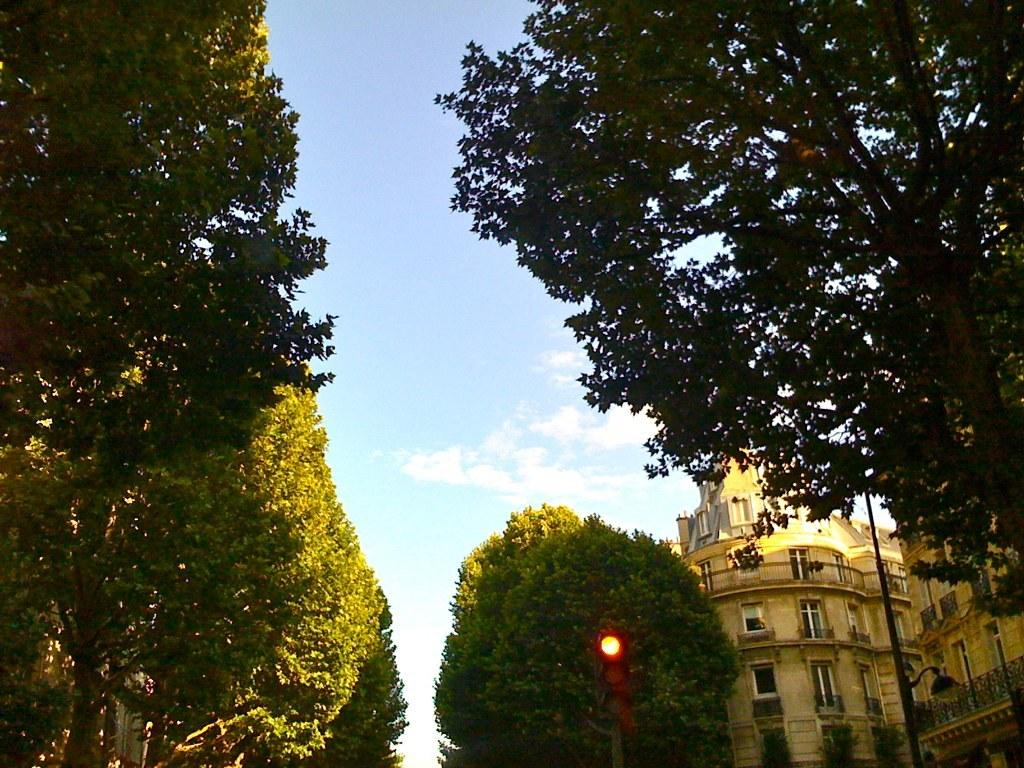What type of vegetation can be seen on both sides of the image? There are trees on both sides of the image. What structure is located on the right side of the image? There is a brown color building on the right side of the image. What type of windows does the building have? The building has glass windows. Where is the humor located in the image? There is no humor present in the image. Is there a jail visible in the image? There is no jail present in the image. 